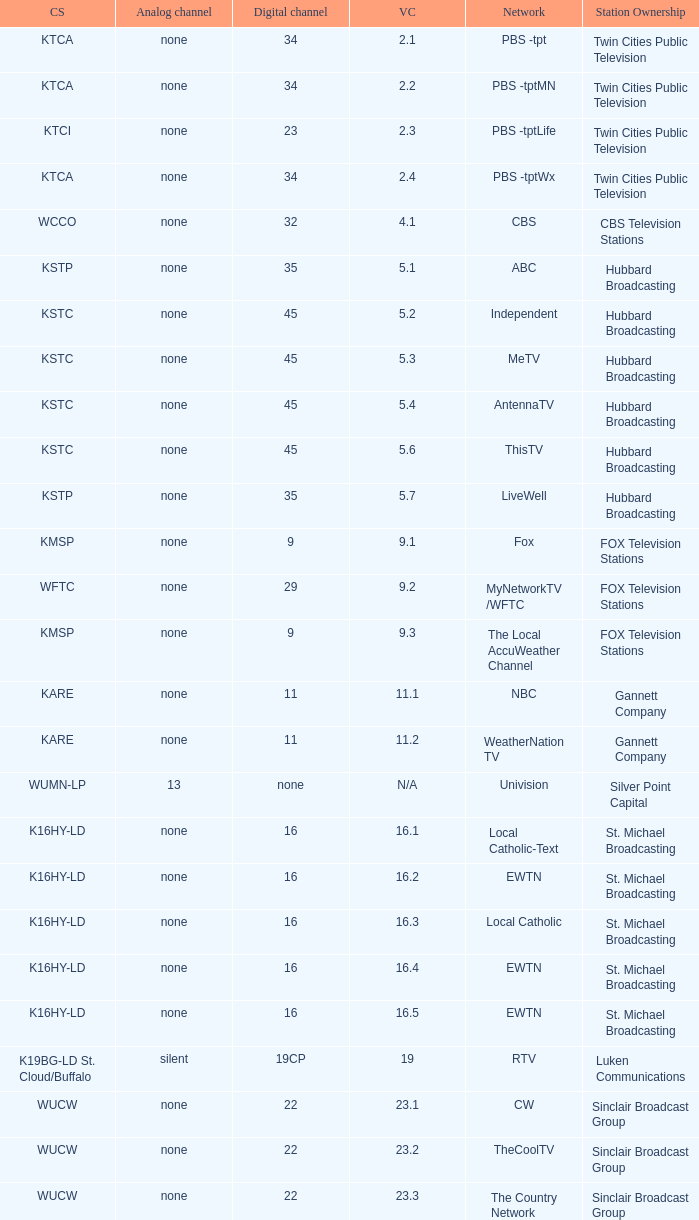Call sign of k33ln-ld, and a Virtual channel of 33.5 is what network? 3ABN Radio-Audio. 